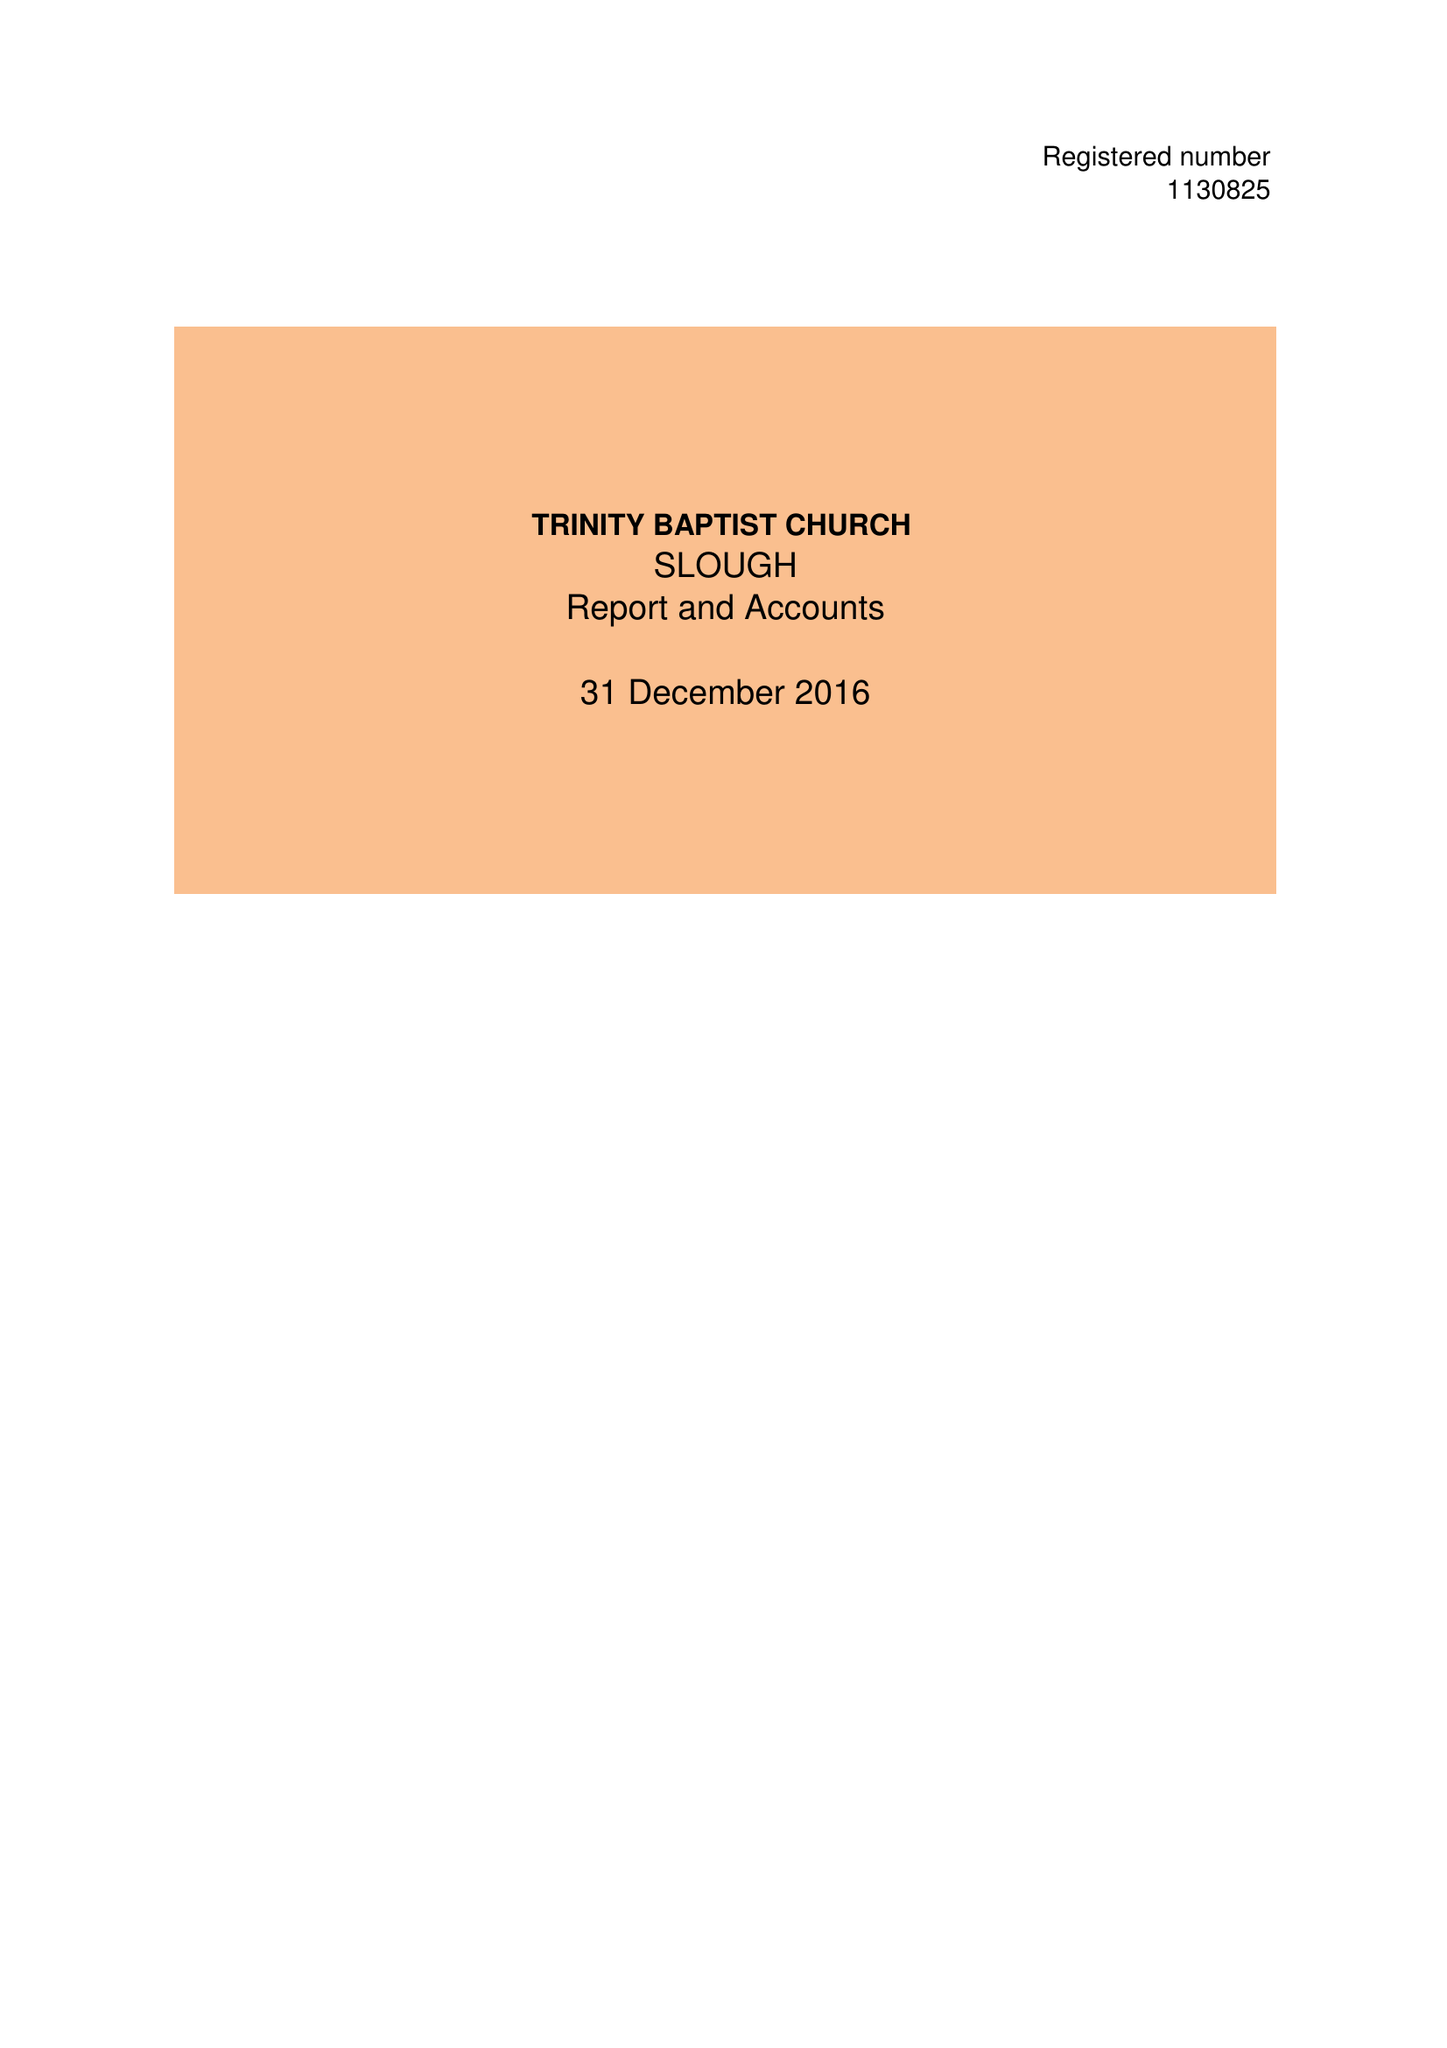What is the value for the spending_annually_in_british_pounds?
Answer the question using a single word or phrase. 40894.00 